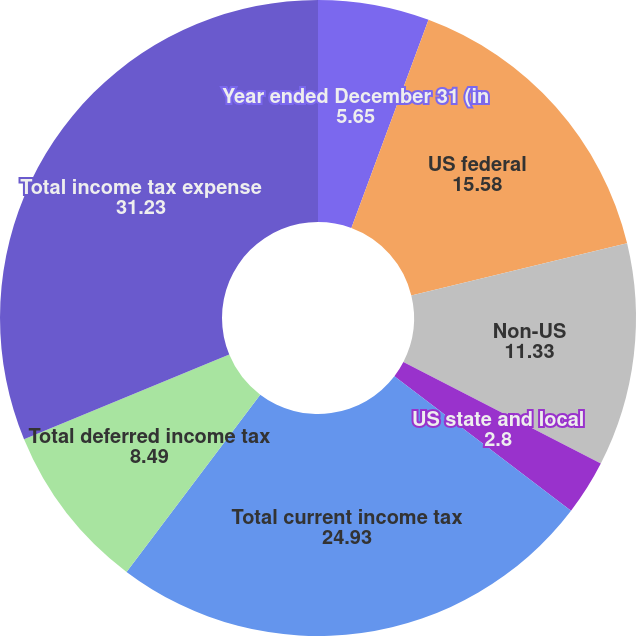Convert chart. <chart><loc_0><loc_0><loc_500><loc_500><pie_chart><fcel>Year ended December 31 (in<fcel>US federal<fcel>Non-US<fcel>US state and local<fcel>Total current income tax<fcel>Total deferred income tax<fcel>Total income tax expense<nl><fcel>5.65%<fcel>15.58%<fcel>11.33%<fcel>2.8%<fcel>24.93%<fcel>8.49%<fcel>31.23%<nl></chart> 